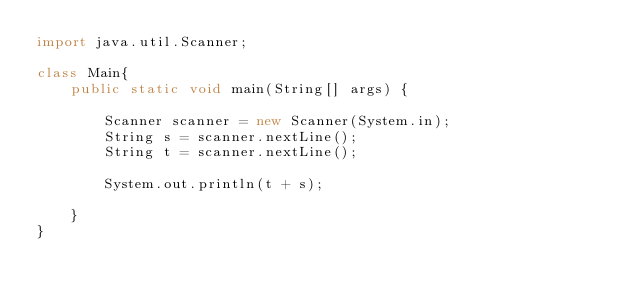<code> <loc_0><loc_0><loc_500><loc_500><_Java_>import java.util.Scanner;

class Main{
    public static void main(String[] args) {

        Scanner scanner = new Scanner(System.in);
        String s = scanner.nextLine();
        String t = scanner.nextLine();

        System.out.println(t + s);

    }
}
</code> 